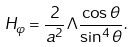<formula> <loc_0><loc_0><loc_500><loc_500>H _ { \varphi } = \frac { 2 } { a ^ { 2 } } \Lambda \frac { \cos \theta } { \sin ^ { 4 } \theta } .</formula> 